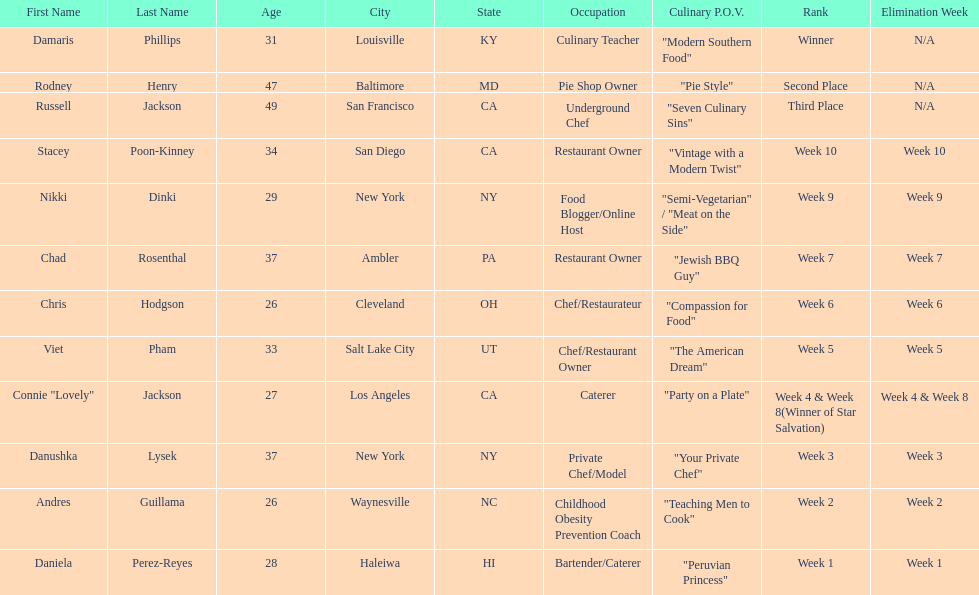Which contestant's culinary point of view had a longer description than "vintage with a modern twist"? Nikki Dinki. 